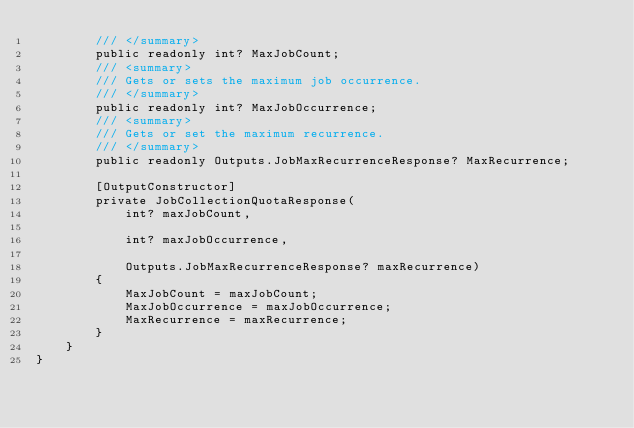<code> <loc_0><loc_0><loc_500><loc_500><_C#_>        /// </summary>
        public readonly int? MaxJobCount;
        /// <summary>
        /// Gets or sets the maximum job occurrence.
        /// </summary>
        public readonly int? MaxJobOccurrence;
        /// <summary>
        /// Gets or set the maximum recurrence.
        /// </summary>
        public readonly Outputs.JobMaxRecurrenceResponse? MaxRecurrence;

        [OutputConstructor]
        private JobCollectionQuotaResponse(
            int? maxJobCount,

            int? maxJobOccurrence,

            Outputs.JobMaxRecurrenceResponse? maxRecurrence)
        {
            MaxJobCount = maxJobCount;
            MaxJobOccurrence = maxJobOccurrence;
            MaxRecurrence = maxRecurrence;
        }
    }
}
</code> 